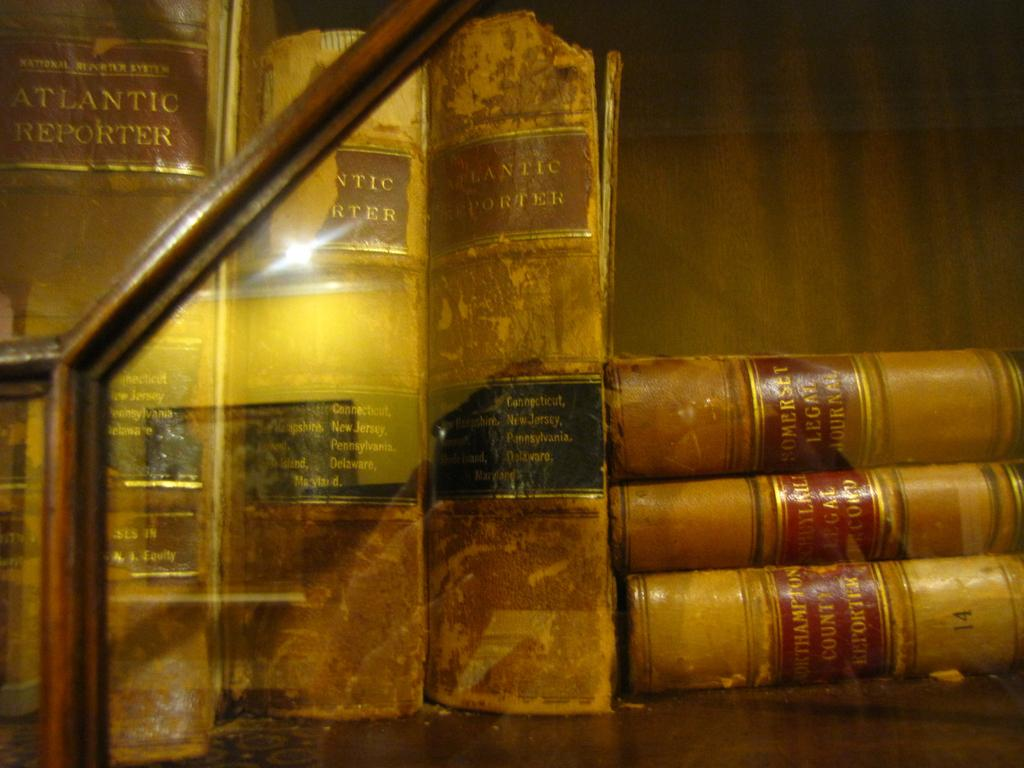<image>
Summarize the visual content of the image. Old leather bound books for the Atlantic Reporter 